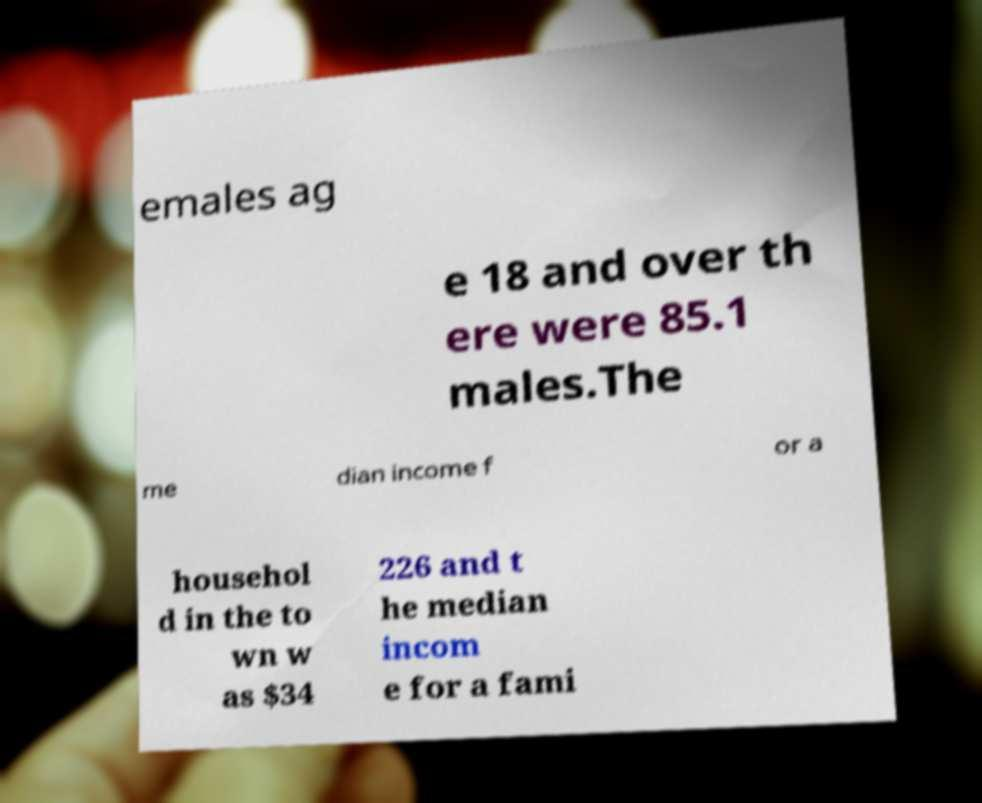Could you extract and type out the text from this image? emales ag e 18 and over th ere were 85.1 males.The me dian income f or a househol d in the to wn w as $34 226 and t he median incom e for a fami 